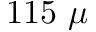<formula> <loc_0><loc_0><loc_500><loc_500>1 1 5 \mu</formula> 